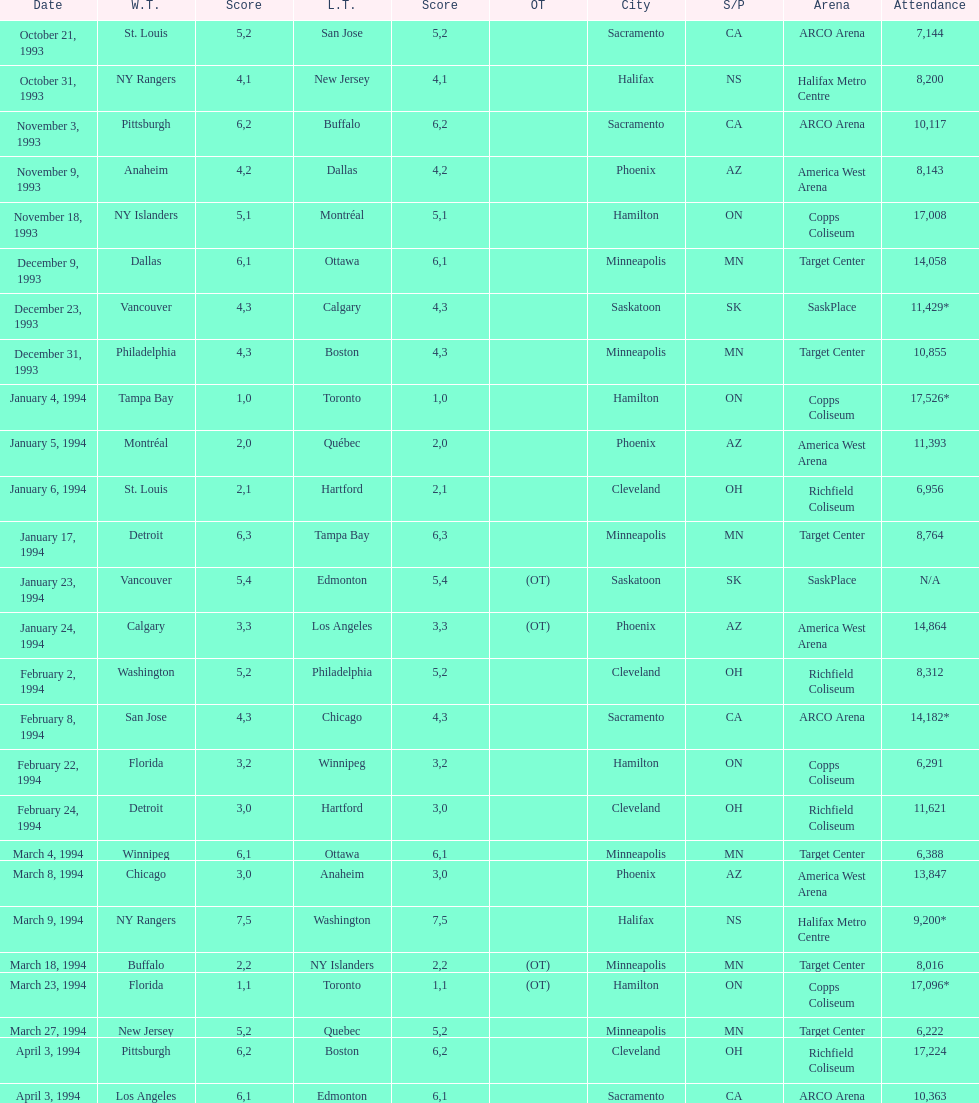What is the difference in attendance between the november 18, 1993 games and the november 9th game? 8865. Can you parse all the data within this table? {'header': ['Date', 'W.T.', 'Score', 'L.T.', 'Score', 'OT', 'City', 'S/P', 'Arena', 'Attendance'], 'rows': [['October 21, 1993', 'St. Louis', '5', 'San Jose', '2', '', 'Sacramento', 'CA', 'ARCO Arena', '7,144'], ['October 31, 1993', 'NY Rangers', '4', 'New Jersey', '1', '', 'Halifax', 'NS', 'Halifax Metro Centre', '8,200'], ['November 3, 1993', 'Pittsburgh', '6', 'Buffalo', '2', '', 'Sacramento', 'CA', 'ARCO Arena', '10,117'], ['November 9, 1993', 'Anaheim', '4', 'Dallas', '2', '', 'Phoenix', 'AZ', 'America West Arena', '8,143'], ['November 18, 1993', 'NY Islanders', '5', 'Montréal', '1', '', 'Hamilton', 'ON', 'Copps Coliseum', '17,008'], ['December 9, 1993', 'Dallas', '6', 'Ottawa', '1', '', 'Minneapolis', 'MN', 'Target Center', '14,058'], ['December 23, 1993', 'Vancouver', '4', 'Calgary', '3', '', 'Saskatoon', 'SK', 'SaskPlace', '11,429*'], ['December 31, 1993', 'Philadelphia', '4', 'Boston', '3', '', 'Minneapolis', 'MN', 'Target Center', '10,855'], ['January 4, 1994', 'Tampa Bay', '1', 'Toronto', '0', '', 'Hamilton', 'ON', 'Copps Coliseum', '17,526*'], ['January 5, 1994', 'Montréal', '2', 'Québec', '0', '', 'Phoenix', 'AZ', 'America West Arena', '11,393'], ['January 6, 1994', 'St. Louis', '2', 'Hartford', '1', '', 'Cleveland', 'OH', 'Richfield Coliseum', '6,956'], ['January 17, 1994', 'Detroit', '6', 'Tampa Bay', '3', '', 'Minneapolis', 'MN', 'Target Center', '8,764'], ['January 23, 1994', 'Vancouver', '5', 'Edmonton', '4', '(OT)', 'Saskatoon', 'SK', 'SaskPlace', 'N/A'], ['January 24, 1994', 'Calgary', '3', 'Los Angeles', '3', '(OT)', 'Phoenix', 'AZ', 'America West Arena', '14,864'], ['February 2, 1994', 'Washington', '5', 'Philadelphia', '2', '', 'Cleveland', 'OH', 'Richfield Coliseum', '8,312'], ['February 8, 1994', 'San Jose', '4', 'Chicago', '3', '', 'Sacramento', 'CA', 'ARCO Arena', '14,182*'], ['February 22, 1994', 'Florida', '3', 'Winnipeg', '2', '', 'Hamilton', 'ON', 'Copps Coliseum', '6,291'], ['February 24, 1994', 'Detroit', '3', 'Hartford', '0', '', 'Cleveland', 'OH', 'Richfield Coliseum', '11,621'], ['March 4, 1994', 'Winnipeg', '6', 'Ottawa', '1', '', 'Minneapolis', 'MN', 'Target Center', '6,388'], ['March 8, 1994', 'Chicago', '3', 'Anaheim', '0', '', 'Phoenix', 'AZ', 'America West Arena', '13,847'], ['March 9, 1994', 'NY Rangers', '7', 'Washington', '5', '', 'Halifax', 'NS', 'Halifax Metro Centre', '9,200*'], ['March 18, 1994', 'Buffalo', '2', 'NY Islanders', '2', '(OT)', 'Minneapolis', 'MN', 'Target Center', '8,016'], ['March 23, 1994', 'Florida', '1', 'Toronto', '1', '(OT)', 'Hamilton', 'ON', 'Copps Coliseum', '17,096*'], ['March 27, 1994', 'New Jersey', '5', 'Quebec', '2', '', 'Minneapolis', 'MN', 'Target Center', '6,222'], ['April 3, 1994', 'Pittsburgh', '6', 'Boston', '2', '', 'Cleveland', 'OH', 'Richfield Coliseum', '17,224'], ['April 3, 1994', 'Los Angeles', '6', 'Edmonton', '1', '', 'Sacramento', 'CA', 'ARCO Arena', '10,363']]} 